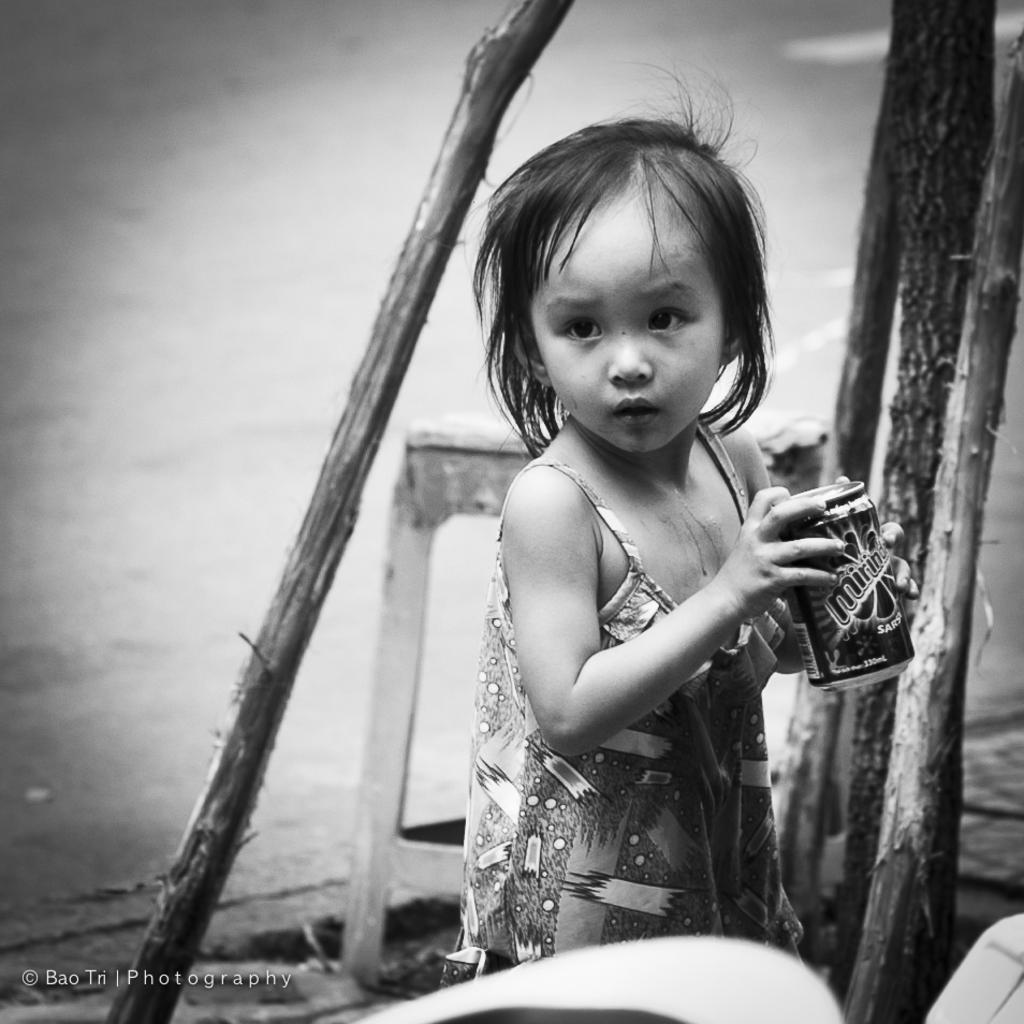What is the main subject of the image? There is a girl child in the image. Where is the girl child located in the image? The girl child is standing on a path. What is the girl child holding in her hands? The girl child is holding a tin in her hands. What other objects can be seen in the image? There are bamboo sticks visible in the image, and there is a stool behind the girl child. What type of pin can be seen in the girl child's hair in the image? There is no pin visible in the girl child's hair in the image. How much dust is present on the path where the girl child is standing? The image does not provide information about the amount of dust on the path. 